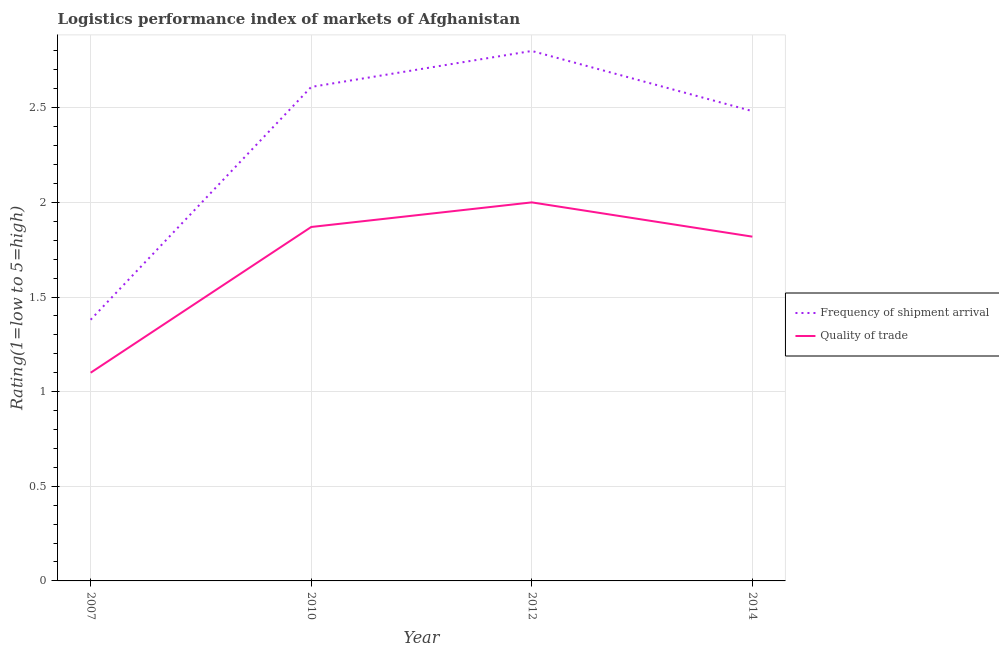Is the number of lines equal to the number of legend labels?
Ensure brevity in your answer.  Yes. Across all years, what is the minimum lpi quality of trade?
Make the answer very short. 1.1. In which year was the lpi quality of trade maximum?
Give a very brief answer. 2012. What is the total lpi quality of trade in the graph?
Offer a very short reply. 6.79. What is the difference between the lpi quality of trade in 2012 and that in 2014?
Ensure brevity in your answer.  0.18. What is the difference between the lpi of frequency of shipment arrival in 2007 and the lpi quality of trade in 2014?
Provide a short and direct response. -0.44. What is the average lpi quality of trade per year?
Your answer should be compact. 1.7. In the year 2014, what is the difference between the lpi quality of trade and lpi of frequency of shipment arrival?
Keep it short and to the point. -0.66. In how many years, is the lpi of frequency of shipment arrival greater than 0.7?
Make the answer very short. 4. What is the ratio of the lpi of frequency of shipment arrival in 2007 to that in 2014?
Offer a terse response. 0.56. What is the difference between the highest and the second highest lpi quality of trade?
Make the answer very short. 0.13. What is the difference between the highest and the lowest lpi of frequency of shipment arrival?
Your answer should be very brief. 1.42. In how many years, is the lpi of frequency of shipment arrival greater than the average lpi of frequency of shipment arrival taken over all years?
Your response must be concise. 3. Is the sum of the lpi quality of trade in 2007 and 2014 greater than the maximum lpi of frequency of shipment arrival across all years?
Make the answer very short. Yes. Does the lpi of frequency of shipment arrival monotonically increase over the years?
Make the answer very short. No. Is the lpi of frequency of shipment arrival strictly less than the lpi quality of trade over the years?
Your answer should be compact. No. How many lines are there?
Your answer should be compact. 2. How many years are there in the graph?
Offer a very short reply. 4. Are the values on the major ticks of Y-axis written in scientific E-notation?
Provide a short and direct response. No. Does the graph contain grids?
Offer a terse response. Yes. Where does the legend appear in the graph?
Keep it short and to the point. Center right. How many legend labels are there?
Provide a short and direct response. 2. What is the title of the graph?
Keep it short and to the point. Logistics performance index of markets of Afghanistan. Does "GDP at market prices" appear as one of the legend labels in the graph?
Give a very brief answer. No. What is the label or title of the X-axis?
Provide a succinct answer. Year. What is the label or title of the Y-axis?
Your answer should be compact. Rating(1=low to 5=high). What is the Rating(1=low to 5=high) in Frequency of shipment arrival in 2007?
Give a very brief answer. 1.38. What is the Rating(1=low to 5=high) of Frequency of shipment arrival in 2010?
Ensure brevity in your answer.  2.61. What is the Rating(1=low to 5=high) of Quality of trade in 2010?
Give a very brief answer. 1.87. What is the Rating(1=low to 5=high) of Frequency of shipment arrival in 2014?
Keep it short and to the point. 2.48. What is the Rating(1=low to 5=high) of Quality of trade in 2014?
Provide a succinct answer. 1.82. Across all years, what is the maximum Rating(1=low to 5=high) of Frequency of shipment arrival?
Your answer should be compact. 2.8. Across all years, what is the minimum Rating(1=low to 5=high) of Frequency of shipment arrival?
Ensure brevity in your answer.  1.38. Across all years, what is the minimum Rating(1=low to 5=high) in Quality of trade?
Provide a succinct answer. 1.1. What is the total Rating(1=low to 5=high) in Frequency of shipment arrival in the graph?
Make the answer very short. 9.27. What is the total Rating(1=low to 5=high) in Quality of trade in the graph?
Provide a succinct answer. 6.79. What is the difference between the Rating(1=low to 5=high) of Frequency of shipment arrival in 2007 and that in 2010?
Make the answer very short. -1.23. What is the difference between the Rating(1=low to 5=high) of Quality of trade in 2007 and that in 2010?
Give a very brief answer. -0.77. What is the difference between the Rating(1=low to 5=high) in Frequency of shipment arrival in 2007 and that in 2012?
Keep it short and to the point. -1.42. What is the difference between the Rating(1=low to 5=high) of Frequency of shipment arrival in 2007 and that in 2014?
Provide a short and direct response. -1.1. What is the difference between the Rating(1=low to 5=high) in Quality of trade in 2007 and that in 2014?
Give a very brief answer. -0.72. What is the difference between the Rating(1=low to 5=high) in Frequency of shipment arrival in 2010 and that in 2012?
Offer a terse response. -0.19. What is the difference between the Rating(1=low to 5=high) in Quality of trade in 2010 and that in 2012?
Give a very brief answer. -0.13. What is the difference between the Rating(1=low to 5=high) of Frequency of shipment arrival in 2010 and that in 2014?
Provide a short and direct response. 0.13. What is the difference between the Rating(1=low to 5=high) in Quality of trade in 2010 and that in 2014?
Your response must be concise. 0.05. What is the difference between the Rating(1=low to 5=high) of Frequency of shipment arrival in 2012 and that in 2014?
Give a very brief answer. 0.32. What is the difference between the Rating(1=low to 5=high) in Quality of trade in 2012 and that in 2014?
Make the answer very short. 0.18. What is the difference between the Rating(1=low to 5=high) in Frequency of shipment arrival in 2007 and the Rating(1=low to 5=high) in Quality of trade in 2010?
Your answer should be compact. -0.49. What is the difference between the Rating(1=low to 5=high) in Frequency of shipment arrival in 2007 and the Rating(1=low to 5=high) in Quality of trade in 2012?
Give a very brief answer. -0.62. What is the difference between the Rating(1=low to 5=high) of Frequency of shipment arrival in 2007 and the Rating(1=low to 5=high) of Quality of trade in 2014?
Ensure brevity in your answer.  -0.44. What is the difference between the Rating(1=low to 5=high) of Frequency of shipment arrival in 2010 and the Rating(1=low to 5=high) of Quality of trade in 2012?
Offer a terse response. 0.61. What is the difference between the Rating(1=low to 5=high) of Frequency of shipment arrival in 2010 and the Rating(1=low to 5=high) of Quality of trade in 2014?
Keep it short and to the point. 0.79. What is the difference between the Rating(1=low to 5=high) in Frequency of shipment arrival in 2012 and the Rating(1=low to 5=high) in Quality of trade in 2014?
Your answer should be compact. 0.98. What is the average Rating(1=low to 5=high) in Frequency of shipment arrival per year?
Offer a terse response. 2.32. What is the average Rating(1=low to 5=high) of Quality of trade per year?
Your answer should be very brief. 1.7. In the year 2007, what is the difference between the Rating(1=low to 5=high) of Frequency of shipment arrival and Rating(1=low to 5=high) of Quality of trade?
Offer a terse response. 0.28. In the year 2010, what is the difference between the Rating(1=low to 5=high) in Frequency of shipment arrival and Rating(1=low to 5=high) in Quality of trade?
Your answer should be very brief. 0.74. In the year 2012, what is the difference between the Rating(1=low to 5=high) in Frequency of shipment arrival and Rating(1=low to 5=high) in Quality of trade?
Offer a very short reply. 0.8. In the year 2014, what is the difference between the Rating(1=low to 5=high) in Frequency of shipment arrival and Rating(1=low to 5=high) in Quality of trade?
Your answer should be compact. 0.66. What is the ratio of the Rating(1=low to 5=high) of Frequency of shipment arrival in 2007 to that in 2010?
Give a very brief answer. 0.53. What is the ratio of the Rating(1=low to 5=high) of Quality of trade in 2007 to that in 2010?
Make the answer very short. 0.59. What is the ratio of the Rating(1=low to 5=high) of Frequency of shipment arrival in 2007 to that in 2012?
Offer a very short reply. 0.49. What is the ratio of the Rating(1=low to 5=high) in Quality of trade in 2007 to that in 2012?
Make the answer very short. 0.55. What is the ratio of the Rating(1=low to 5=high) in Frequency of shipment arrival in 2007 to that in 2014?
Offer a terse response. 0.56. What is the ratio of the Rating(1=low to 5=high) in Quality of trade in 2007 to that in 2014?
Offer a terse response. 0.6. What is the ratio of the Rating(1=low to 5=high) of Frequency of shipment arrival in 2010 to that in 2012?
Offer a terse response. 0.93. What is the ratio of the Rating(1=low to 5=high) of Quality of trade in 2010 to that in 2012?
Your response must be concise. 0.94. What is the ratio of the Rating(1=low to 5=high) of Frequency of shipment arrival in 2010 to that in 2014?
Make the answer very short. 1.05. What is the ratio of the Rating(1=low to 5=high) in Quality of trade in 2010 to that in 2014?
Your answer should be very brief. 1.03. What is the ratio of the Rating(1=low to 5=high) of Frequency of shipment arrival in 2012 to that in 2014?
Provide a short and direct response. 1.13. What is the ratio of the Rating(1=low to 5=high) of Quality of trade in 2012 to that in 2014?
Your answer should be very brief. 1.1. What is the difference between the highest and the second highest Rating(1=low to 5=high) in Frequency of shipment arrival?
Provide a succinct answer. 0.19. What is the difference between the highest and the second highest Rating(1=low to 5=high) of Quality of trade?
Provide a succinct answer. 0.13. What is the difference between the highest and the lowest Rating(1=low to 5=high) of Frequency of shipment arrival?
Your answer should be compact. 1.42. What is the difference between the highest and the lowest Rating(1=low to 5=high) of Quality of trade?
Offer a terse response. 0.9. 